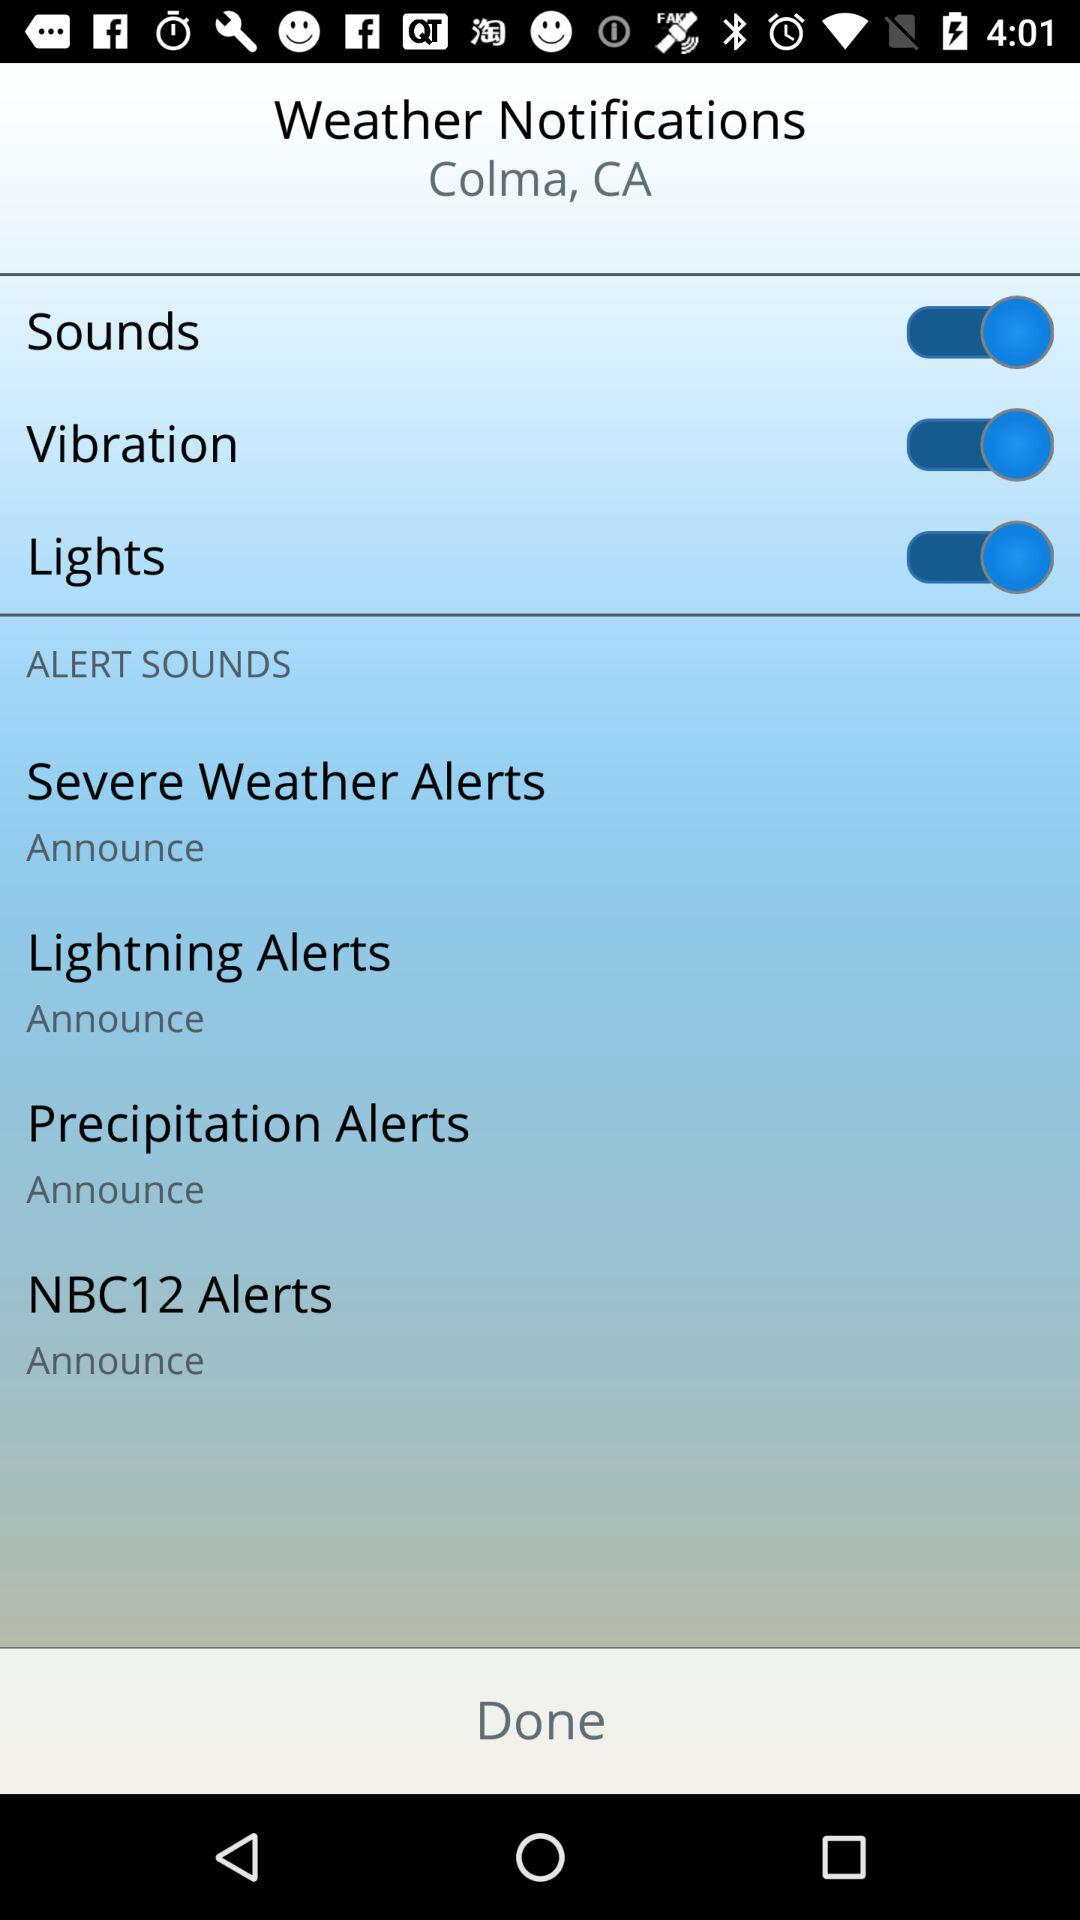How many alerts have an announce option?
Answer the question using a single word or phrase. 4 